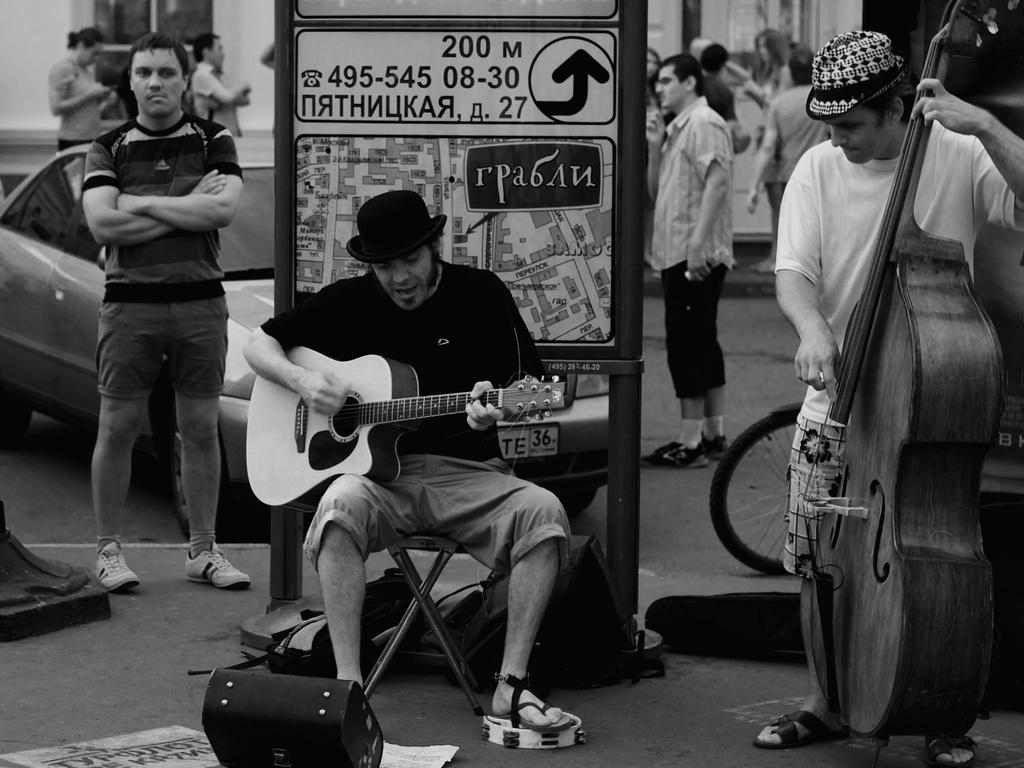What is the main activity being performed by the person in the image? There is a person playing a guitar in the image. What can be seen in the background of the image? There is a car in the background of the image. Can you describe the other person in the image? There is another person standing in the image. What is the additional object featured in the image? There is a poster in the image. What type of vehicle is present in the image? There is a vehicle in the image. What type of book is the person reading while playing the guitar in the image? There is no book present in the image, and the person is not reading while playing the guitar. What is the texture of the dress worn by the person playing the guitar in the image? There is no dress mentioned in the image, and the person is not wearing a dress. 